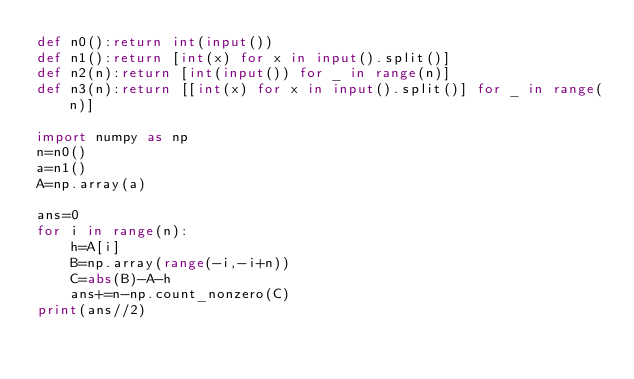Convert code to text. <code><loc_0><loc_0><loc_500><loc_500><_Python_>def n0():return int(input())
def n1():return [int(x) for x in input().split()]
def n2(n):return [int(input()) for _ in range(n)]
def n3(n):return [[int(x) for x in input().split()] for _ in range(n)]

import numpy as np
n=n0()
a=n1()
A=np.array(a)

ans=0
for i in range(n):
    h=A[i]
    B=np.array(range(-i,-i+n))
    C=abs(B)-A-h
    ans+=n-np.count_nonzero(C)
print(ans//2)</code> 